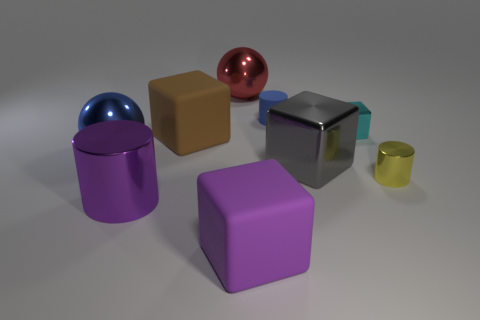There is a thing that is the same color as the large cylinder; what material is it?
Provide a short and direct response. Rubber. Do the cube in front of the yellow metal cylinder and the big shiny cylinder have the same color?
Ensure brevity in your answer.  Yes. Is the color of the rubber cube that is in front of the large brown rubber object the same as the metal cylinder to the left of the gray block?
Your answer should be very brief. Yes. Is the size of the metal cylinder that is right of the red metal sphere the same as the brown object?
Provide a short and direct response. No. The small cyan metallic object is what shape?
Make the answer very short. Cube. What size is the other thing that is the same color as the tiny matte thing?
Ensure brevity in your answer.  Large. Is the material of the big ball that is in front of the tiny cyan block the same as the small blue thing?
Offer a terse response. No. Is there another thing that has the same color as the tiny rubber object?
Your answer should be compact. Yes. Is the shape of the big shiny object that is right of the tiny blue object the same as the rubber thing to the left of the big purple cube?
Ensure brevity in your answer.  Yes. Is there a brown object that has the same material as the tiny cyan thing?
Your answer should be very brief. No. 